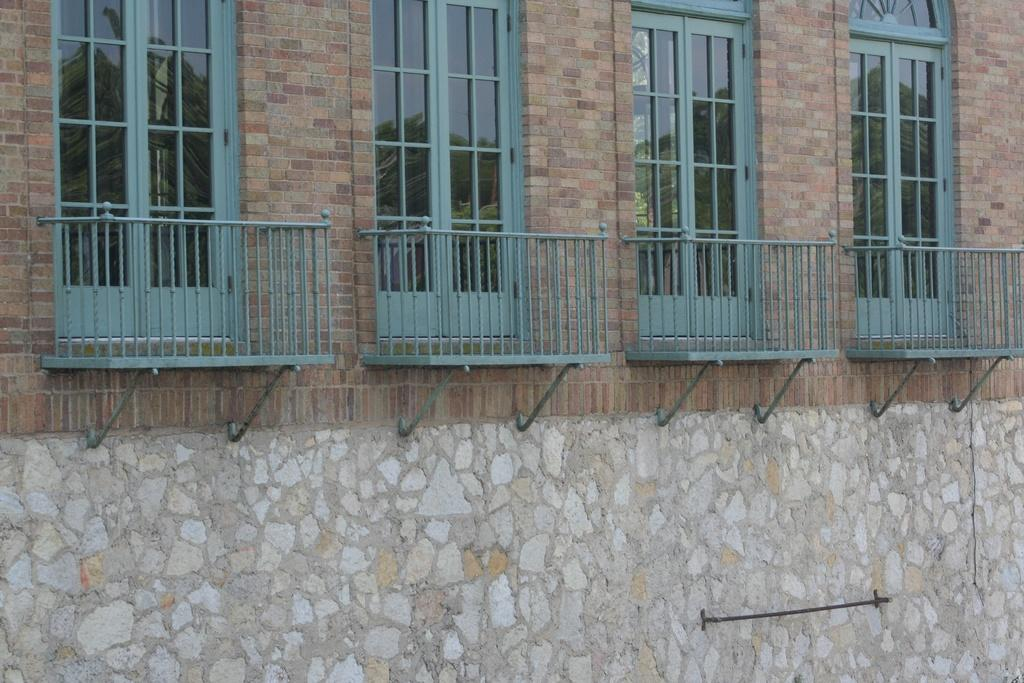What type of doors are visible in the image? There are glass doors in the image. Where are the glass doors located? The glass doors are part of a wall. What type of brake system is installed on the glass doors in the image? There is no brake system present on the glass doors in the image, as they are not a vehicle or machinery. 